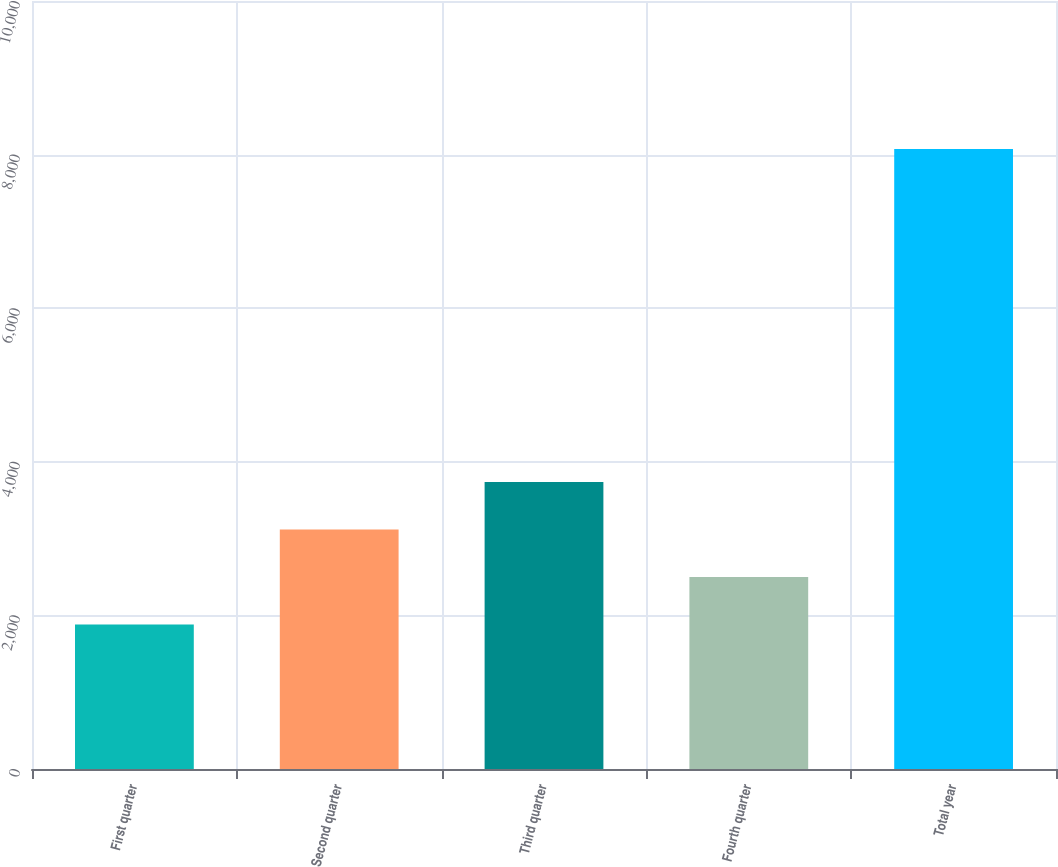Convert chart to OTSL. <chart><loc_0><loc_0><loc_500><loc_500><bar_chart><fcel>First quarter<fcel>Second quarter<fcel>Third quarter<fcel>Fourth quarter<fcel>Total year<nl><fcel>1881.2<fcel>3119.28<fcel>3738.32<fcel>2500.24<fcel>8071.6<nl></chart> 